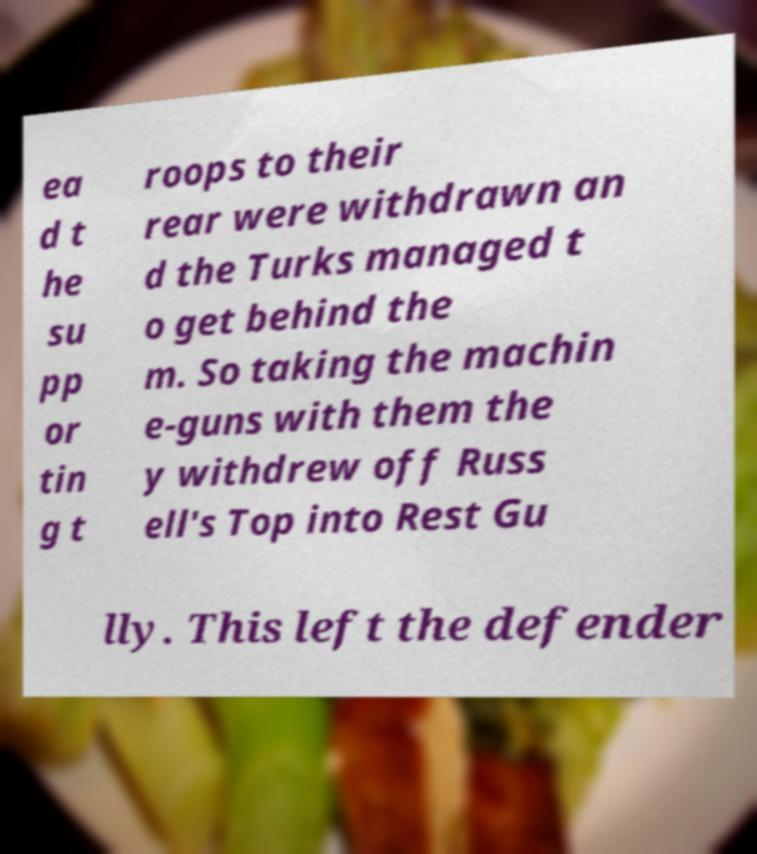Could you extract and type out the text from this image? ea d t he su pp or tin g t roops to their rear were withdrawn an d the Turks managed t o get behind the m. So taking the machin e-guns with them the y withdrew off Russ ell's Top into Rest Gu lly. This left the defender 